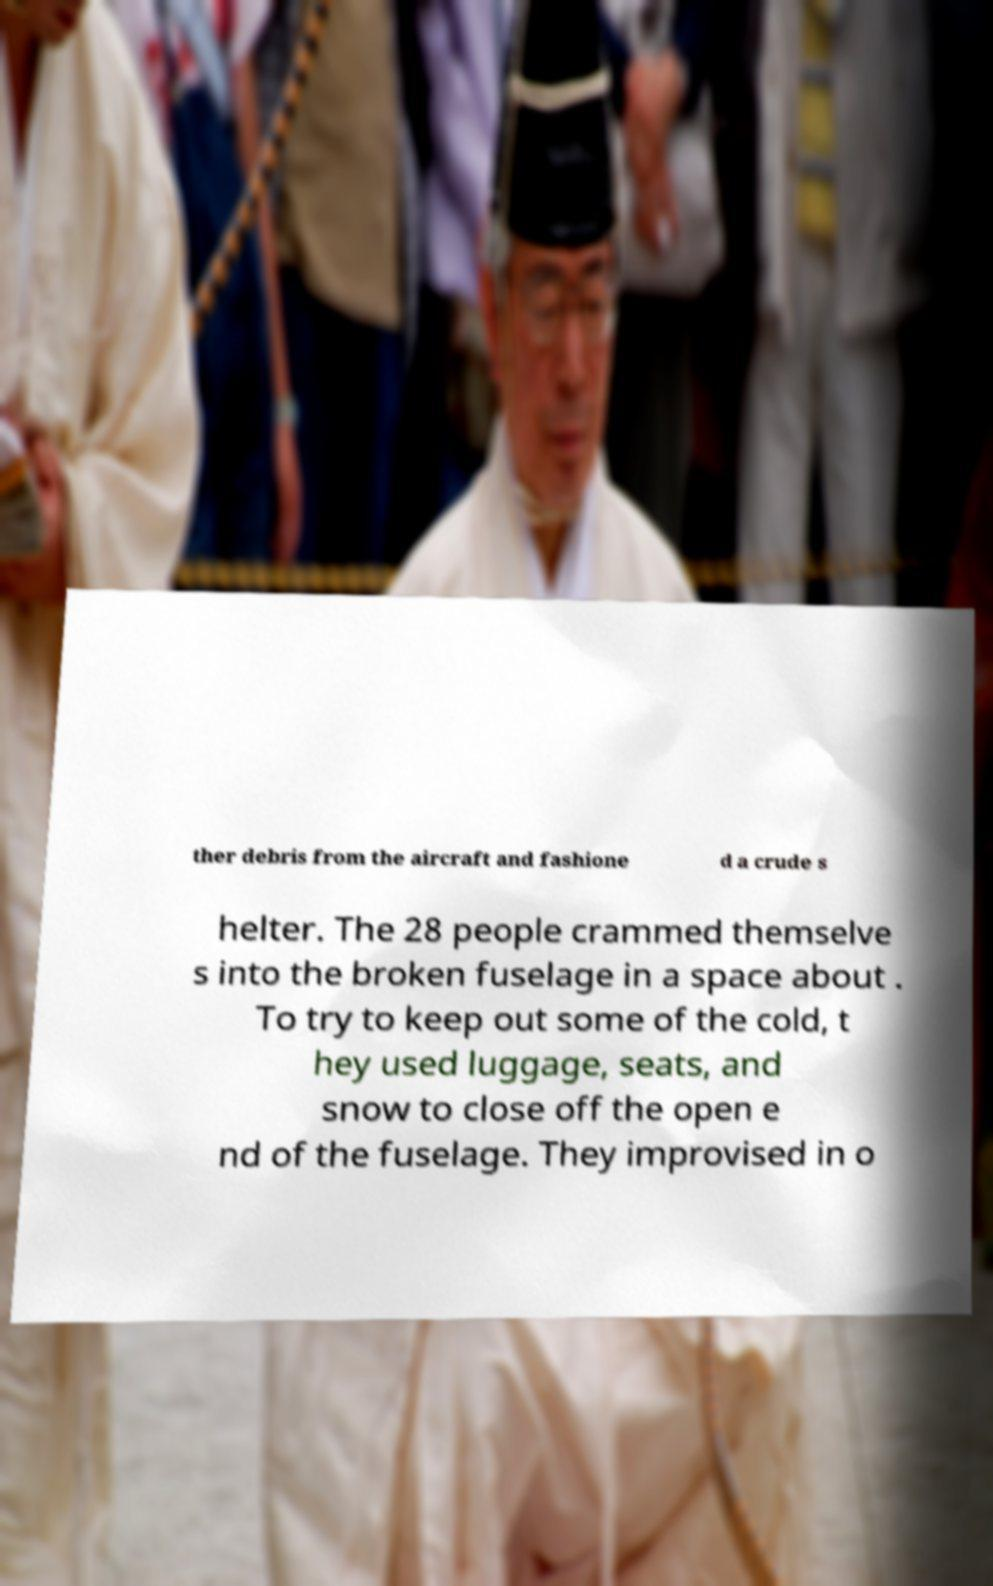Please read and relay the text visible in this image. What does it say? ther debris from the aircraft and fashione d a crude s helter. The 28 people crammed themselve s into the broken fuselage in a space about . To try to keep out some of the cold, t hey used luggage, seats, and snow to close off the open e nd of the fuselage. They improvised in o 